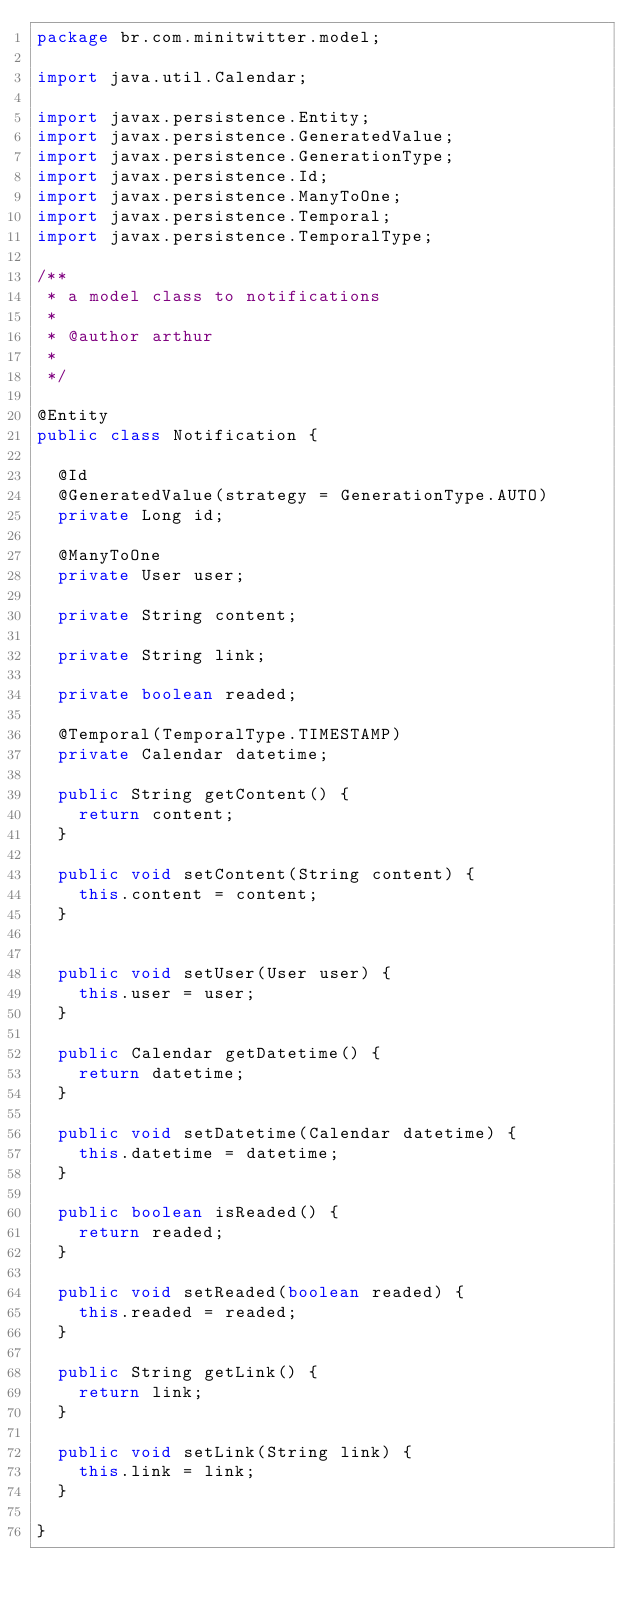Convert code to text. <code><loc_0><loc_0><loc_500><loc_500><_Java_>package br.com.minitwitter.model;

import java.util.Calendar;

import javax.persistence.Entity;
import javax.persistence.GeneratedValue;
import javax.persistence.GenerationType;
import javax.persistence.Id;
import javax.persistence.ManyToOne;
import javax.persistence.Temporal;
import javax.persistence.TemporalType;

/**
 * a model class to notifications
 * 
 * @author arthur
 *
 */

@Entity
public class Notification {
  
  @Id
  @GeneratedValue(strategy = GenerationType.AUTO)
  private Long id;
  
  @ManyToOne
  private User user;
  
  private String content;
  
  private String link;
  
  private boolean readed;
  
  @Temporal(TemporalType.TIMESTAMP)
  private Calendar datetime;

  public String getContent() {
    return content;
  }

  public void setContent(String content) {
    this.content = content;
  }


  public void setUser(User user) {
    this.user = user;
  }

  public Calendar getDatetime() {
    return datetime;
  }

  public void setDatetime(Calendar datetime) {
    this.datetime = datetime;
  }

  public boolean isReaded() {
    return readed;
  }

  public void setReaded(boolean readed) {
    this.readed = readed;
  }

  public String getLink() {
    return link;
  }

  public void setLink(String link) {
    this.link = link;
  }

}
</code> 